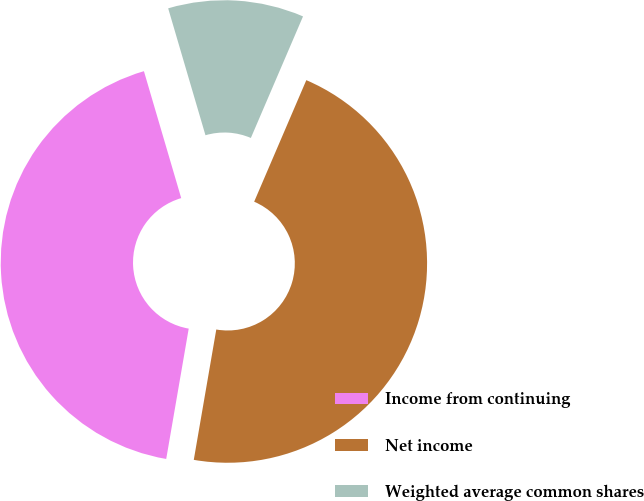<chart> <loc_0><loc_0><loc_500><loc_500><pie_chart><fcel>Income from continuing<fcel>Net income<fcel>Weighted average common shares<nl><fcel>42.73%<fcel>46.27%<fcel>11.0%<nl></chart> 